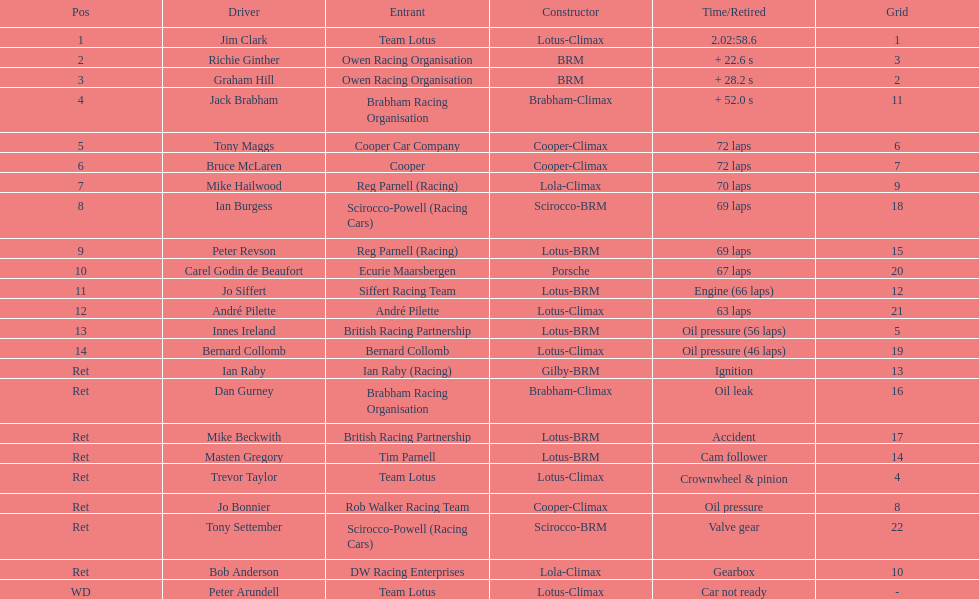Who achieved the best finish driving a cooper-climax vehicle? Tony Maggs. 